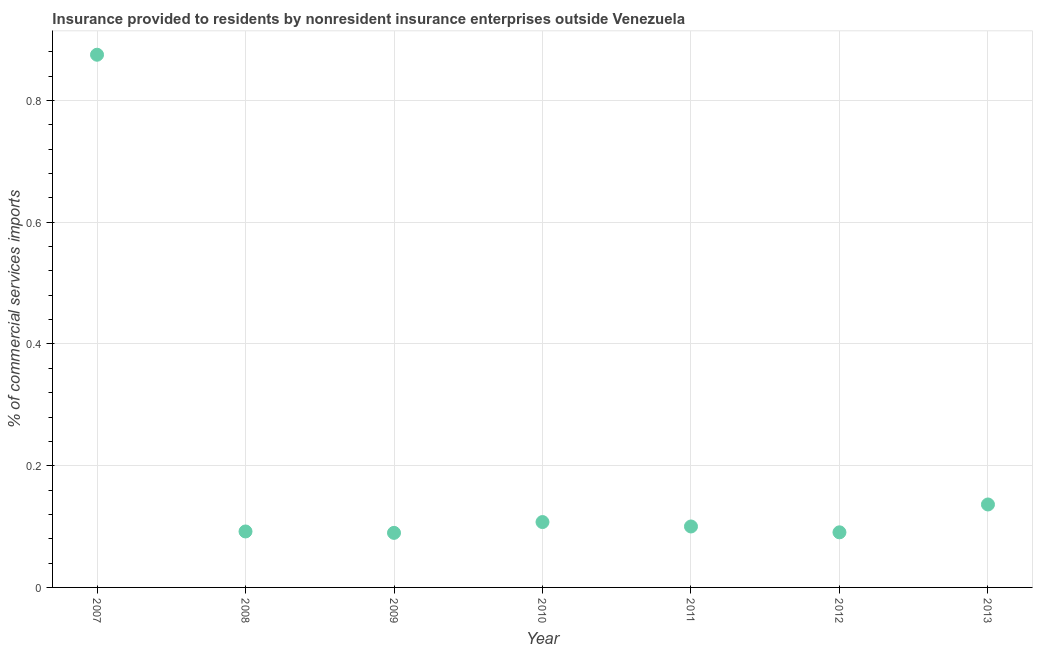What is the insurance provided by non-residents in 2009?
Your answer should be very brief. 0.09. Across all years, what is the maximum insurance provided by non-residents?
Give a very brief answer. 0.88. Across all years, what is the minimum insurance provided by non-residents?
Make the answer very short. 0.09. In which year was the insurance provided by non-residents minimum?
Offer a very short reply. 2009. What is the sum of the insurance provided by non-residents?
Give a very brief answer. 1.49. What is the difference between the insurance provided by non-residents in 2010 and 2012?
Offer a very short reply. 0.02. What is the average insurance provided by non-residents per year?
Offer a terse response. 0.21. What is the median insurance provided by non-residents?
Provide a succinct answer. 0.1. In how many years, is the insurance provided by non-residents greater than 0.52 %?
Your response must be concise. 1. Do a majority of the years between 2009 and 2011 (inclusive) have insurance provided by non-residents greater than 0.36 %?
Offer a terse response. No. What is the ratio of the insurance provided by non-residents in 2007 to that in 2011?
Offer a terse response. 8.74. Is the difference between the insurance provided by non-residents in 2009 and 2013 greater than the difference between any two years?
Give a very brief answer. No. What is the difference between the highest and the second highest insurance provided by non-residents?
Make the answer very short. 0.74. What is the difference between the highest and the lowest insurance provided by non-residents?
Your answer should be compact. 0.79. Does the graph contain any zero values?
Ensure brevity in your answer.  No. What is the title of the graph?
Ensure brevity in your answer.  Insurance provided to residents by nonresident insurance enterprises outside Venezuela. What is the label or title of the X-axis?
Offer a very short reply. Year. What is the label or title of the Y-axis?
Offer a terse response. % of commercial services imports. What is the % of commercial services imports in 2007?
Provide a short and direct response. 0.88. What is the % of commercial services imports in 2008?
Keep it short and to the point. 0.09. What is the % of commercial services imports in 2009?
Your answer should be very brief. 0.09. What is the % of commercial services imports in 2010?
Keep it short and to the point. 0.11. What is the % of commercial services imports in 2011?
Keep it short and to the point. 0.1. What is the % of commercial services imports in 2012?
Keep it short and to the point. 0.09. What is the % of commercial services imports in 2013?
Provide a short and direct response. 0.14. What is the difference between the % of commercial services imports in 2007 and 2008?
Offer a terse response. 0.78. What is the difference between the % of commercial services imports in 2007 and 2009?
Make the answer very short. 0.79. What is the difference between the % of commercial services imports in 2007 and 2010?
Ensure brevity in your answer.  0.77. What is the difference between the % of commercial services imports in 2007 and 2011?
Your answer should be compact. 0.78. What is the difference between the % of commercial services imports in 2007 and 2012?
Offer a very short reply. 0.78. What is the difference between the % of commercial services imports in 2007 and 2013?
Give a very brief answer. 0.74. What is the difference between the % of commercial services imports in 2008 and 2009?
Provide a short and direct response. 0. What is the difference between the % of commercial services imports in 2008 and 2010?
Give a very brief answer. -0.02. What is the difference between the % of commercial services imports in 2008 and 2011?
Your answer should be very brief. -0.01. What is the difference between the % of commercial services imports in 2008 and 2012?
Your answer should be compact. 0. What is the difference between the % of commercial services imports in 2008 and 2013?
Give a very brief answer. -0.04. What is the difference between the % of commercial services imports in 2009 and 2010?
Your answer should be compact. -0.02. What is the difference between the % of commercial services imports in 2009 and 2011?
Your response must be concise. -0.01. What is the difference between the % of commercial services imports in 2009 and 2012?
Your answer should be compact. -0. What is the difference between the % of commercial services imports in 2009 and 2013?
Offer a very short reply. -0.05. What is the difference between the % of commercial services imports in 2010 and 2011?
Give a very brief answer. 0.01. What is the difference between the % of commercial services imports in 2010 and 2012?
Provide a short and direct response. 0.02. What is the difference between the % of commercial services imports in 2010 and 2013?
Your answer should be compact. -0.03. What is the difference between the % of commercial services imports in 2011 and 2012?
Your answer should be very brief. 0.01. What is the difference between the % of commercial services imports in 2011 and 2013?
Your response must be concise. -0.04. What is the difference between the % of commercial services imports in 2012 and 2013?
Provide a short and direct response. -0.05. What is the ratio of the % of commercial services imports in 2007 to that in 2008?
Give a very brief answer. 9.52. What is the ratio of the % of commercial services imports in 2007 to that in 2009?
Offer a terse response. 9.76. What is the ratio of the % of commercial services imports in 2007 to that in 2010?
Give a very brief answer. 8.15. What is the ratio of the % of commercial services imports in 2007 to that in 2011?
Your response must be concise. 8.74. What is the ratio of the % of commercial services imports in 2007 to that in 2012?
Offer a very short reply. 9.67. What is the ratio of the % of commercial services imports in 2007 to that in 2013?
Provide a succinct answer. 6.42. What is the ratio of the % of commercial services imports in 2008 to that in 2010?
Your response must be concise. 0.86. What is the ratio of the % of commercial services imports in 2008 to that in 2011?
Give a very brief answer. 0.92. What is the ratio of the % of commercial services imports in 2008 to that in 2012?
Provide a succinct answer. 1.02. What is the ratio of the % of commercial services imports in 2008 to that in 2013?
Keep it short and to the point. 0.68. What is the ratio of the % of commercial services imports in 2009 to that in 2010?
Your answer should be compact. 0.83. What is the ratio of the % of commercial services imports in 2009 to that in 2011?
Make the answer very short. 0.9. What is the ratio of the % of commercial services imports in 2009 to that in 2012?
Give a very brief answer. 0.99. What is the ratio of the % of commercial services imports in 2009 to that in 2013?
Provide a short and direct response. 0.66. What is the ratio of the % of commercial services imports in 2010 to that in 2011?
Your response must be concise. 1.07. What is the ratio of the % of commercial services imports in 2010 to that in 2012?
Give a very brief answer. 1.19. What is the ratio of the % of commercial services imports in 2010 to that in 2013?
Offer a very short reply. 0.79. What is the ratio of the % of commercial services imports in 2011 to that in 2012?
Your answer should be compact. 1.11. What is the ratio of the % of commercial services imports in 2011 to that in 2013?
Ensure brevity in your answer.  0.73. What is the ratio of the % of commercial services imports in 2012 to that in 2013?
Give a very brief answer. 0.66. 